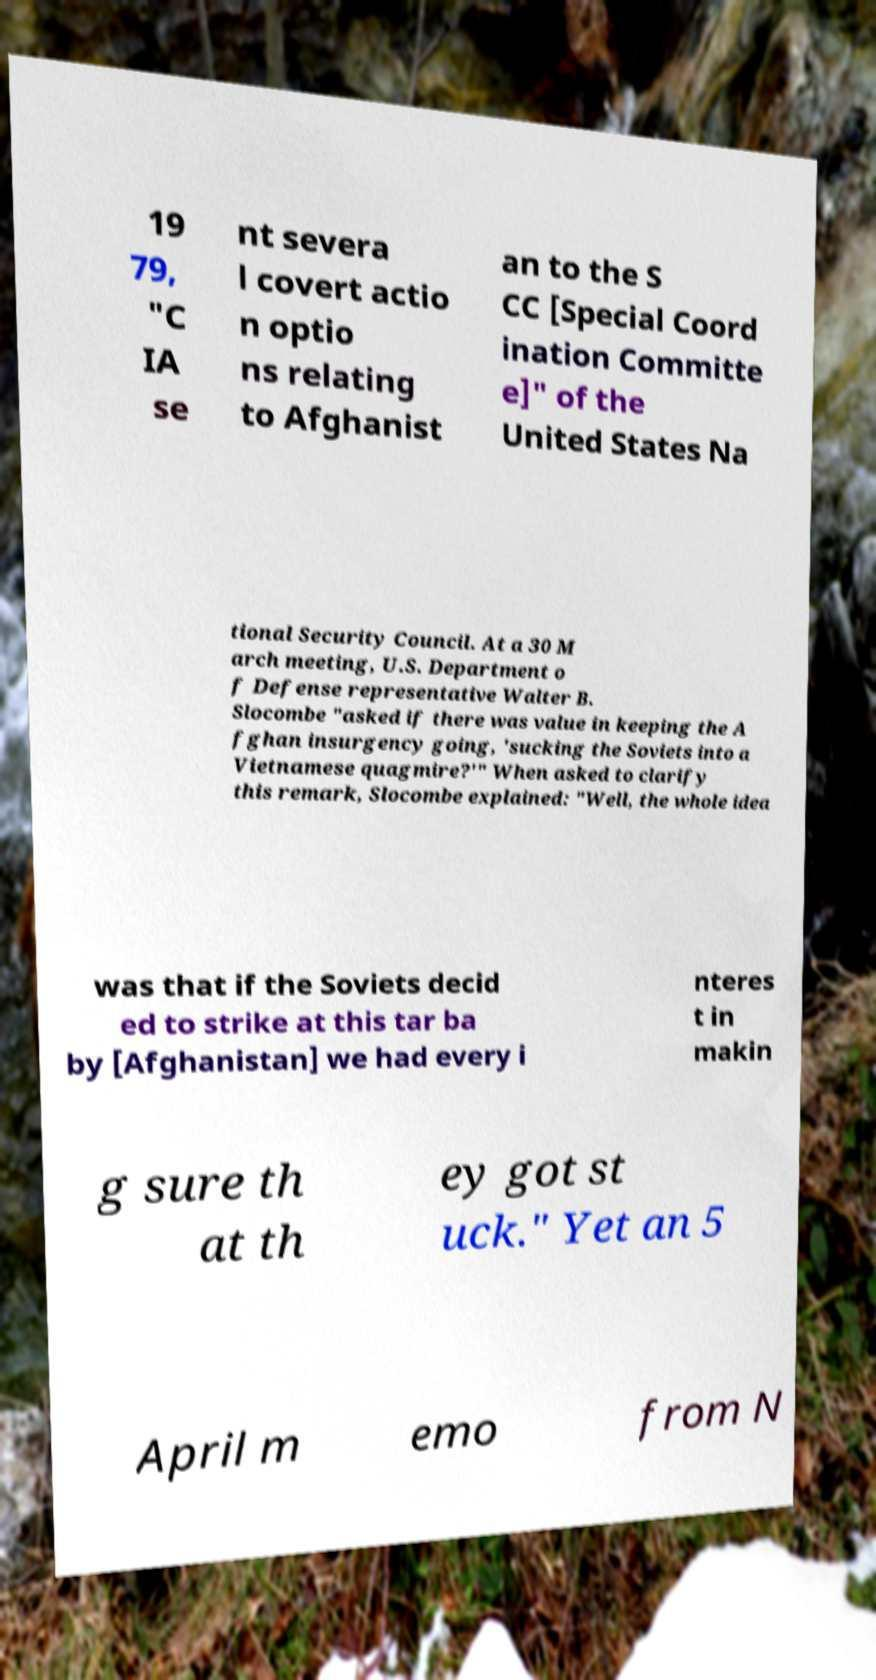Could you assist in decoding the text presented in this image and type it out clearly? 19 79, "C IA se nt severa l covert actio n optio ns relating to Afghanist an to the S CC [Special Coord ination Committe e]" of the United States Na tional Security Council. At a 30 M arch meeting, U.S. Department o f Defense representative Walter B. Slocombe "asked if there was value in keeping the A fghan insurgency going, 'sucking the Soviets into a Vietnamese quagmire?'" When asked to clarify this remark, Slocombe explained: "Well, the whole idea was that if the Soviets decid ed to strike at this tar ba by [Afghanistan] we had every i nteres t in makin g sure th at th ey got st uck." Yet an 5 April m emo from N 